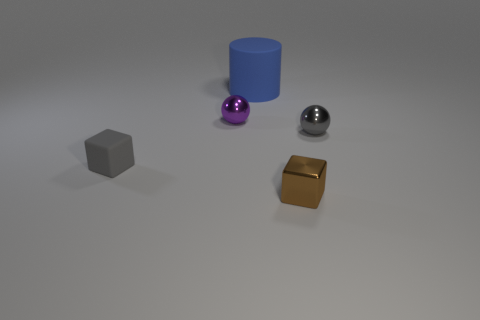What material do the objects appear to be made of? From the look of the image, the objects seem to have different finishes, suggesting different materials. The gray cube and the blue cylinder have a matte finish, hinting at a solid, possibly plastic material. The purple sphere appears to be matte as well, while the tiny ball has a shiny, metallic finish, and the cube looks like it could be metallic with a more reflective golden finish. 